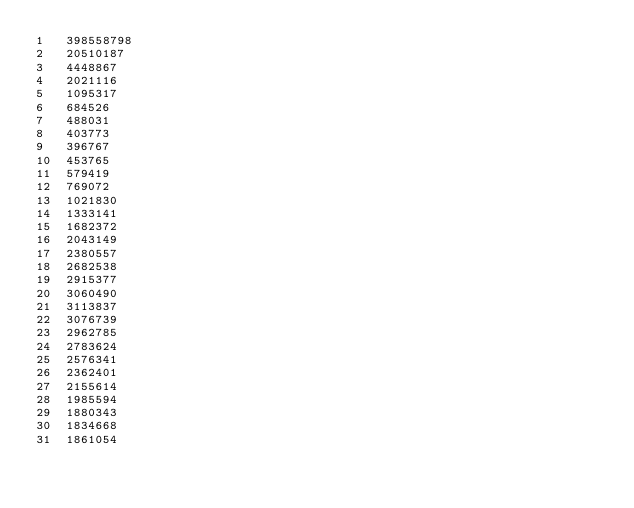<code> <loc_0><loc_0><loc_500><loc_500><_SQL_>1	398558798
2	20510187
3	4448867
4	2021116
5	1095317
6	684526
7	488031
8	403773
9	396767
10	453765
11	579419
12	769072
13	1021830
14	1333141
15	1682372
16	2043149
17	2380557
18	2682538
19	2915377
20	3060490
21	3113837
22	3076739
23	2962785
24	2783624
25	2576341
26	2362401
27	2155614
28	1985594
29	1880343
30	1834668
31	1861054</code> 